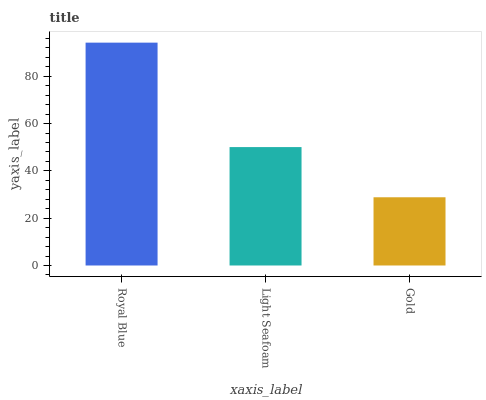Is Gold the minimum?
Answer yes or no. Yes. Is Royal Blue the maximum?
Answer yes or no. Yes. Is Light Seafoam the minimum?
Answer yes or no. No. Is Light Seafoam the maximum?
Answer yes or no. No. Is Royal Blue greater than Light Seafoam?
Answer yes or no. Yes. Is Light Seafoam less than Royal Blue?
Answer yes or no. Yes. Is Light Seafoam greater than Royal Blue?
Answer yes or no. No. Is Royal Blue less than Light Seafoam?
Answer yes or no. No. Is Light Seafoam the high median?
Answer yes or no. Yes. Is Light Seafoam the low median?
Answer yes or no. Yes. Is Gold the high median?
Answer yes or no. No. Is Gold the low median?
Answer yes or no. No. 